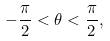<formula> <loc_0><loc_0><loc_500><loc_500>- \frac { \pi } { 2 } < \theta < \frac { \pi } { 2 } ,</formula> 